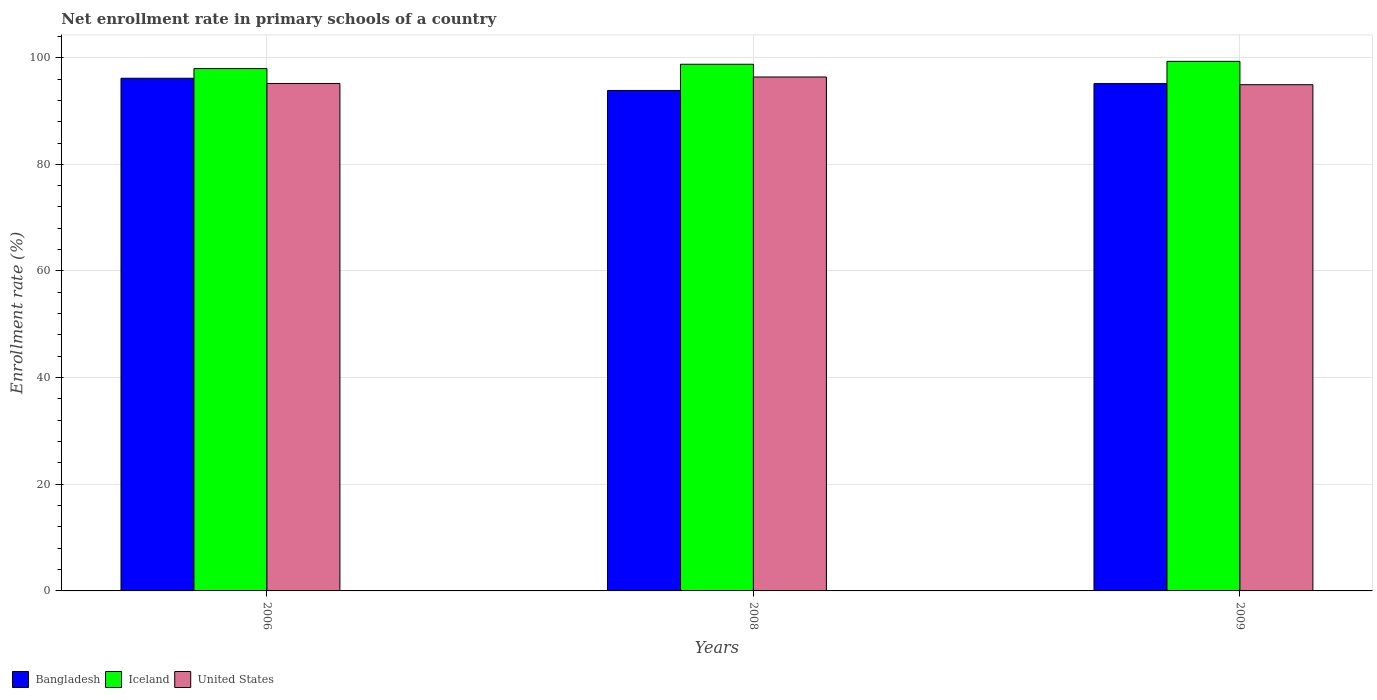How many different coloured bars are there?
Make the answer very short. 3. How many groups of bars are there?
Offer a terse response. 3. Are the number of bars per tick equal to the number of legend labels?
Keep it short and to the point. Yes. Are the number of bars on each tick of the X-axis equal?
Provide a succinct answer. Yes. How many bars are there on the 2nd tick from the left?
Provide a short and direct response. 3. What is the label of the 3rd group of bars from the left?
Your answer should be very brief. 2009. What is the enrollment rate in primary schools in Iceland in 2006?
Offer a very short reply. 97.96. Across all years, what is the maximum enrollment rate in primary schools in United States?
Ensure brevity in your answer.  96.38. Across all years, what is the minimum enrollment rate in primary schools in Bangladesh?
Provide a short and direct response. 93.85. What is the total enrollment rate in primary schools in Bangladesh in the graph?
Offer a very short reply. 285.13. What is the difference between the enrollment rate in primary schools in Iceland in 2006 and that in 2009?
Your answer should be very brief. -1.35. What is the difference between the enrollment rate in primary schools in United States in 2009 and the enrollment rate in primary schools in Iceland in 2006?
Ensure brevity in your answer.  -3.02. What is the average enrollment rate in primary schools in United States per year?
Your response must be concise. 95.49. In the year 2008, what is the difference between the enrollment rate in primary schools in Bangladesh and enrollment rate in primary schools in United States?
Provide a short and direct response. -2.53. What is the ratio of the enrollment rate in primary schools in Iceland in 2006 to that in 2009?
Give a very brief answer. 0.99. Is the enrollment rate in primary schools in Bangladesh in 2006 less than that in 2008?
Offer a terse response. No. Is the difference between the enrollment rate in primary schools in Bangladesh in 2006 and 2009 greater than the difference between the enrollment rate in primary schools in United States in 2006 and 2009?
Provide a short and direct response. Yes. What is the difference between the highest and the second highest enrollment rate in primary schools in Bangladesh?
Offer a very short reply. 1. What is the difference between the highest and the lowest enrollment rate in primary schools in United States?
Your answer should be compact. 1.44. In how many years, is the enrollment rate in primary schools in Iceland greater than the average enrollment rate in primary schools in Iceland taken over all years?
Offer a terse response. 2. Is the sum of the enrollment rate in primary schools in Iceland in 2006 and 2009 greater than the maximum enrollment rate in primary schools in Bangladesh across all years?
Your response must be concise. Yes. What does the 3rd bar from the left in 2008 represents?
Give a very brief answer. United States. Is it the case that in every year, the sum of the enrollment rate in primary schools in Bangladesh and enrollment rate in primary schools in United States is greater than the enrollment rate in primary schools in Iceland?
Ensure brevity in your answer.  Yes. Are all the bars in the graph horizontal?
Ensure brevity in your answer.  No. What is the difference between two consecutive major ticks on the Y-axis?
Provide a succinct answer. 20. Where does the legend appear in the graph?
Make the answer very short. Bottom left. How are the legend labels stacked?
Make the answer very short. Horizontal. What is the title of the graph?
Ensure brevity in your answer.  Net enrollment rate in primary schools of a country. Does "Lebanon" appear as one of the legend labels in the graph?
Keep it short and to the point. No. What is the label or title of the Y-axis?
Ensure brevity in your answer.  Enrollment rate (%). What is the Enrollment rate (%) in Bangladesh in 2006?
Provide a succinct answer. 96.14. What is the Enrollment rate (%) in Iceland in 2006?
Provide a short and direct response. 97.96. What is the Enrollment rate (%) in United States in 2006?
Provide a succinct answer. 95.16. What is the Enrollment rate (%) of Bangladesh in 2008?
Offer a very short reply. 93.85. What is the Enrollment rate (%) of Iceland in 2008?
Make the answer very short. 98.77. What is the Enrollment rate (%) of United States in 2008?
Offer a very short reply. 96.38. What is the Enrollment rate (%) in Bangladesh in 2009?
Keep it short and to the point. 95.14. What is the Enrollment rate (%) in Iceland in 2009?
Give a very brief answer. 99.31. What is the Enrollment rate (%) in United States in 2009?
Provide a succinct answer. 94.93. Across all years, what is the maximum Enrollment rate (%) of Bangladesh?
Offer a terse response. 96.14. Across all years, what is the maximum Enrollment rate (%) in Iceland?
Your answer should be very brief. 99.31. Across all years, what is the maximum Enrollment rate (%) in United States?
Give a very brief answer. 96.38. Across all years, what is the minimum Enrollment rate (%) of Bangladesh?
Offer a terse response. 93.85. Across all years, what is the minimum Enrollment rate (%) of Iceland?
Your answer should be compact. 97.96. Across all years, what is the minimum Enrollment rate (%) in United States?
Offer a terse response. 94.93. What is the total Enrollment rate (%) in Bangladesh in the graph?
Offer a terse response. 285.13. What is the total Enrollment rate (%) of Iceland in the graph?
Provide a succinct answer. 296.04. What is the total Enrollment rate (%) of United States in the graph?
Offer a terse response. 286.47. What is the difference between the Enrollment rate (%) of Bangladesh in 2006 and that in 2008?
Provide a short and direct response. 2.29. What is the difference between the Enrollment rate (%) of Iceland in 2006 and that in 2008?
Provide a short and direct response. -0.81. What is the difference between the Enrollment rate (%) of United States in 2006 and that in 2008?
Offer a terse response. -1.22. What is the difference between the Enrollment rate (%) in Bangladesh in 2006 and that in 2009?
Offer a terse response. 1. What is the difference between the Enrollment rate (%) of Iceland in 2006 and that in 2009?
Give a very brief answer. -1.35. What is the difference between the Enrollment rate (%) of United States in 2006 and that in 2009?
Provide a succinct answer. 0.23. What is the difference between the Enrollment rate (%) of Bangladesh in 2008 and that in 2009?
Your answer should be very brief. -1.29. What is the difference between the Enrollment rate (%) in Iceland in 2008 and that in 2009?
Your answer should be very brief. -0.55. What is the difference between the Enrollment rate (%) of United States in 2008 and that in 2009?
Provide a succinct answer. 1.44. What is the difference between the Enrollment rate (%) of Bangladesh in 2006 and the Enrollment rate (%) of Iceland in 2008?
Make the answer very short. -2.62. What is the difference between the Enrollment rate (%) in Bangladesh in 2006 and the Enrollment rate (%) in United States in 2008?
Provide a short and direct response. -0.23. What is the difference between the Enrollment rate (%) in Iceland in 2006 and the Enrollment rate (%) in United States in 2008?
Ensure brevity in your answer.  1.58. What is the difference between the Enrollment rate (%) in Bangladesh in 2006 and the Enrollment rate (%) in Iceland in 2009?
Ensure brevity in your answer.  -3.17. What is the difference between the Enrollment rate (%) in Bangladesh in 2006 and the Enrollment rate (%) in United States in 2009?
Ensure brevity in your answer.  1.21. What is the difference between the Enrollment rate (%) in Iceland in 2006 and the Enrollment rate (%) in United States in 2009?
Offer a very short reply. 3.02. What is the difference between the Enrollment rate (%) of Bangladesh in 2008 and the Enrollment rate (%) of Iceland in 2009?
Offer a very short reply. -5.46. What is the difference between the Enrollment rate (%) in Bangladesh in 2008 and the Enrollment rate (%) in United States in 2009?
Your response must be concise. -1.09. What is the difference between the Enrollment rate (%) of Iceland in 2008 and the Enrollment rate (%) of United States in 2009?
Keep it short and to the point. 3.83. What is the average Enrollment rate (%) in Bangladesh per year?
Keep it short and to the point. 95.04. What is the average Enrollment rate (%) in Iceland per year?
Give a very brief answer. 98.68. What is the average Enrollment rate (%) in United States per year?
Provide a succinct answer. 95.49. In the year 2006, what is the difference between the Enrollment rate (%) of Bangladesh and Enrollment rate (%) of Iceland?
Make the answer very short. -1.82. In the year 2006, what is the difference between the Enrollment rate (%) in Bangladesh and Enrollment rate (%) in United States?
Keep it short and to the point. 0.98. In the year 2006, what is the difference between the Enrollment rate (%) in Iceland and Enrollment rate (%) in United States?
Keep it short and to the point. 2.8. In the year 2008, what is the difference between the Enrollment rate (%) of Bangladesh and Enrollment rate (%) of Iceland?
Your response must be concise. -4.92. In the year 2008, what is the difference between the Enrollment rate (%) of Bangladesh and Enrollment rate (%) of United States?
Provide a succinct answer. -2.53. In the year 2008, what is the difference between the Enrollment rate (%) in Iceland and Enrollment rate (%) in United States?
Keep it short and to the point. 2.39. In the year 2009, what is the difference between the Enrollment rate (%) of Bangladesh and Enrollment rate (%) of Iceland?
Give a very brief answer. -4.17. In the year 2009, what is the difference between the Enrollment rate (%) in Bangladesh and Enrollment rate (%) in United States?
Provide a short and direct response. 0.2. In the year 2009, what is the difference between the Enrollment rate (%) of Iceland and Enrollment rate (%) of United States?
Provide a succinct answer. 4.38. What is the ratio of the Enrollment rate (%) of Bangladesh in 2006 to that in 2008?
Offer a terse response. 1.02. What is the ratio of the Enrollment rate (%) in Iceland in 2006 to that in 2008?
Your answer should be compact. 0.99. What is the ratio of the Enrollment rate (%) of United States in 2006 to that in 2008?
Your answer should be compact. 0.99. What is the ratio of the Enrollment rate (%) in Bangladesh in 2006 to that in 2009?
Give a very brief answer. 1.01. What is the ratio of the Enrollment rate (%) in Iceland in 2006 to that in 2009?
Your response must be concise. 0.99. What is the ratio of the Enrollment rate (%) in Bangladesh in 2008 to that in 2009?
Your answer should be compact. 0.99. What is the ratio of the Enrollment rate (%) of Iceland in 2008 to that in 2009?
Provide a succinct answer. 0.99. What is the ratio of the Enrollment rate (%) in United States in 2008 to that in 2009?
Ensure brevity in your answer.  1.02. What is the difference between the highest and the second highest Enrollment rate (%) in Iceland?
Your response must be concise. 0.55. What is the difference between the highest and the second highest Enrollment rate (%) in United States?
Your response must be concise. 1.22. What is the difference between the highest and the lowest Enrollment rate (%) in Bangladesh?
Give a very brief answer. 2.29. What is the difference between the highest and the lowest Enrollment rate (%) in Iceland?
Give a very brief answer. 1.35. What is the difference between the highest and the lowest Enrollment rate (%) in United States?
Make the answer very short. 1.44. 